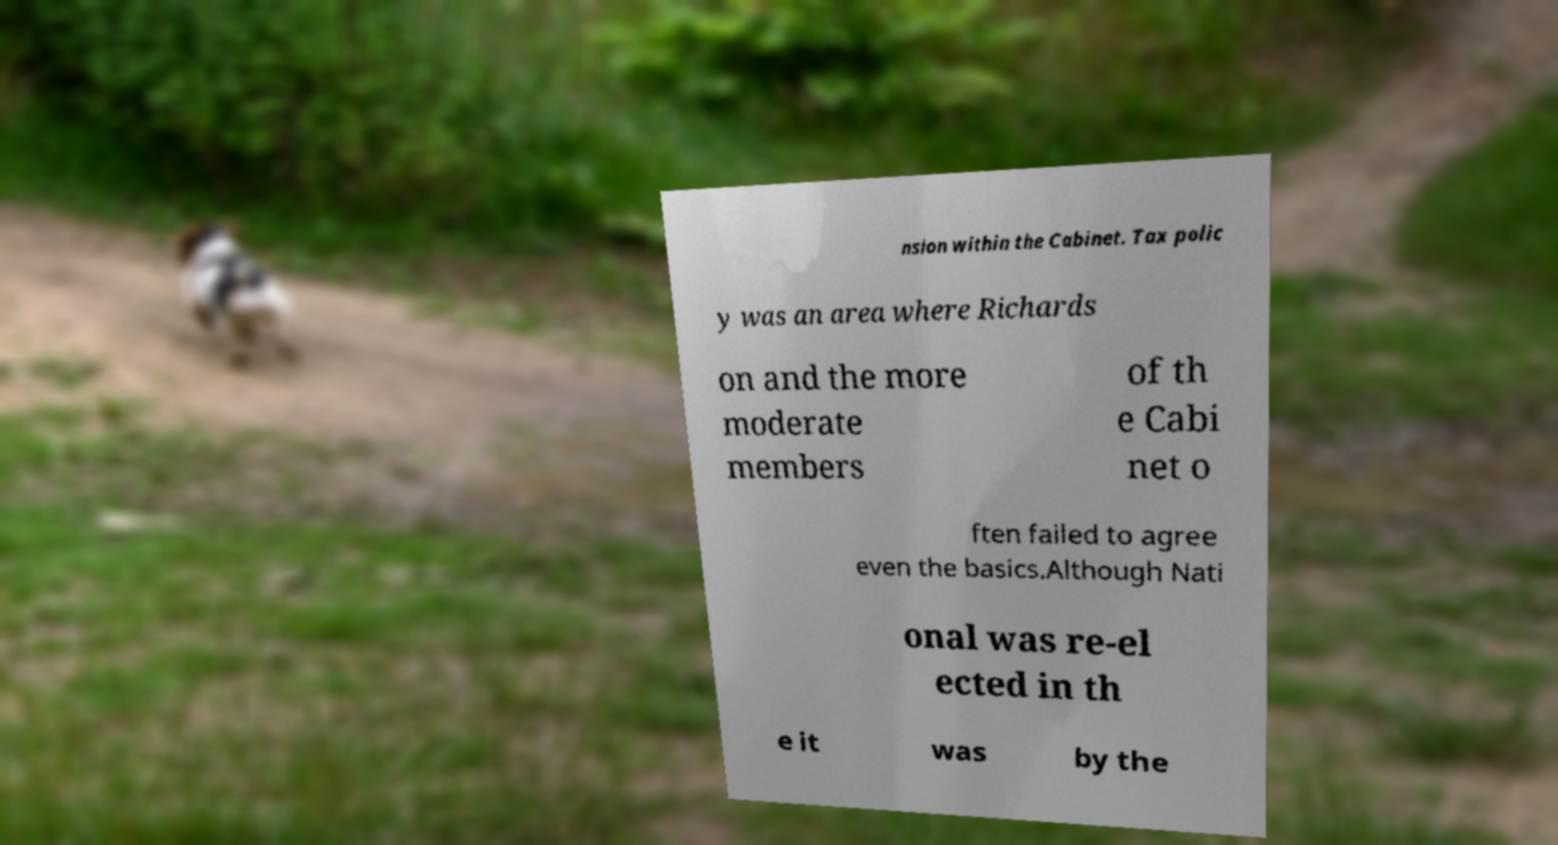Please identify and transcribe the text found in this image. nsion within the Cabinet. Tax polic y was an area where Richards on and the more moderate members of th e Cabi net o ften failed to agree even the basics.Although Nati onal was re-el ected in th e it was by the 